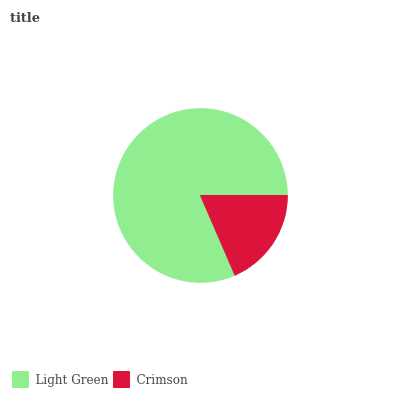Is Crimson the minimum?
Answer yes or no. Yes. Is Light Green the maximum?
Answer yes or no. Yes. Is Crimson the maximum?
Answer yes or no. No. Is Light Green greater than Crimson?
Answer yes or no. Yes. Is Crimson less than Light Green?
Answer yes or no. Yes. Is Crimson greater than Light Green?
Answer yes or no. No. Is Light Green less than Crimson?
Answer yes or no. No. Is Light Green the high median?
Answer yes or no. Yes. Is Crimson the low median?
Answer yes or no. Yes. Is Crimson the high median?
Answer yes or no. No. Is Light Green the low median?
Answer yes or no. No. 